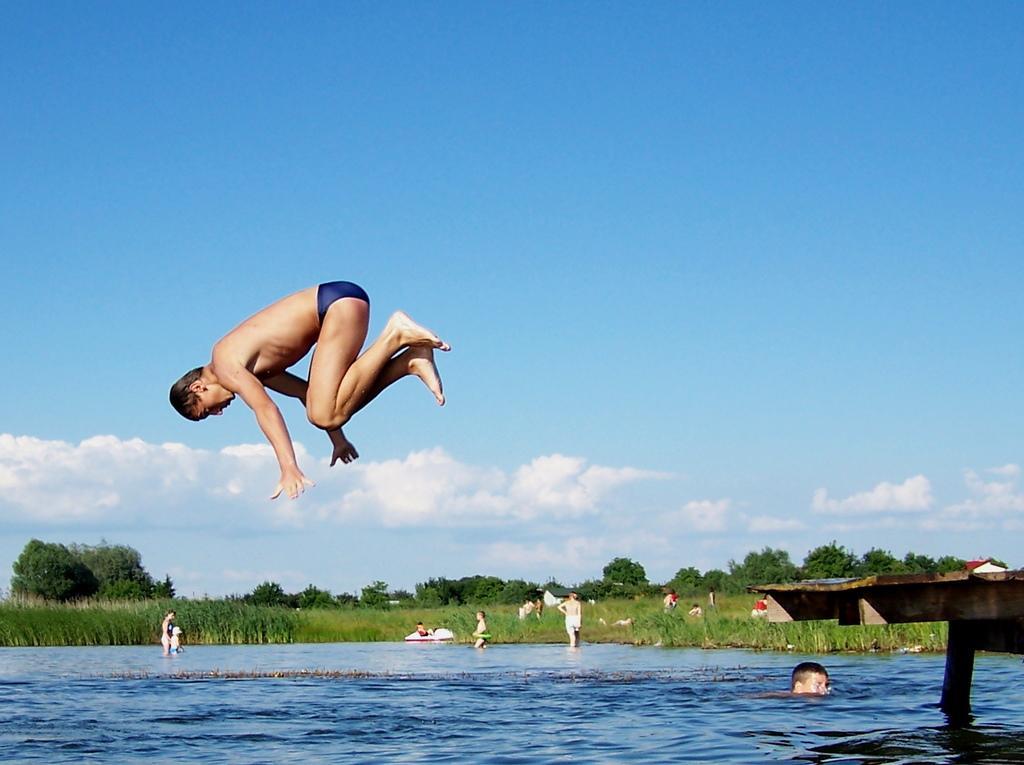Describe this image in one or two sentences. In this image, I can see a person jumping and few people in the water. I can see the trees and plants. On the right side of the image, that looks like a wooden platform. These are the clouds in the sky. 